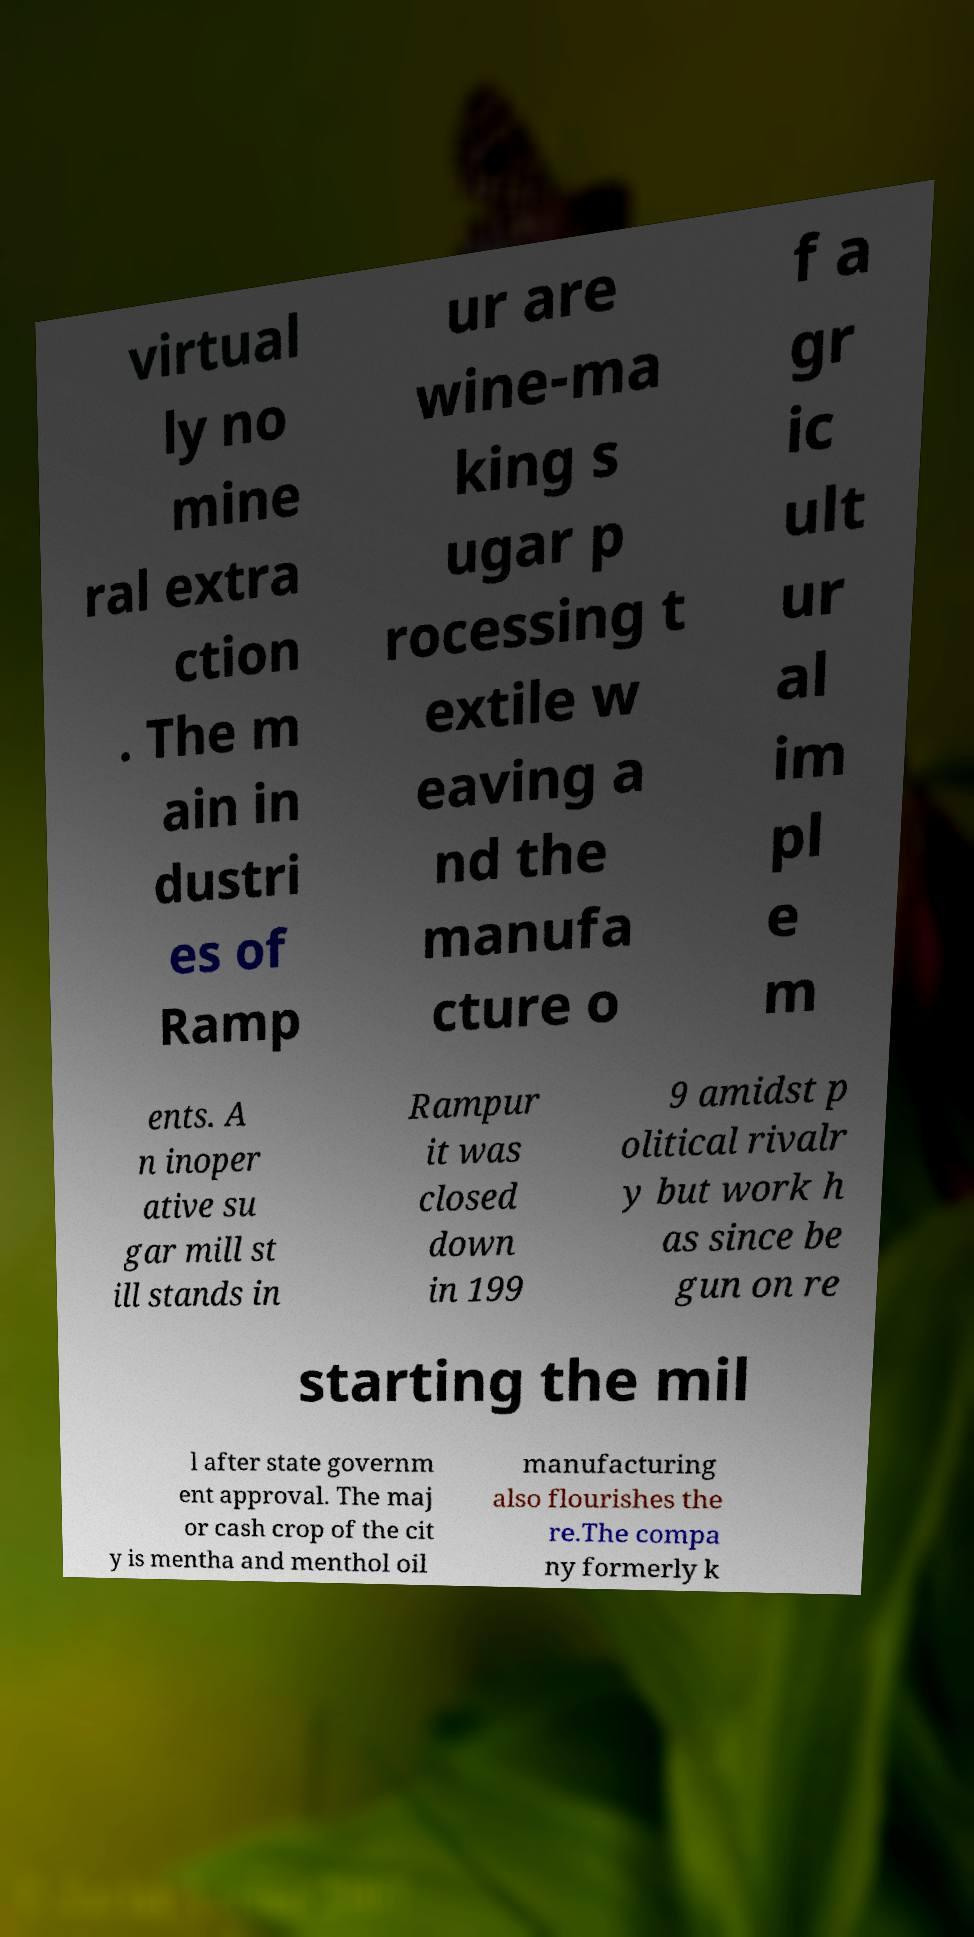Could you assist in decoding the text presented in this image and type it out clearly? virtual ly no mine ral extra ction . The m ain in dustri es of Ramp ur are wine-ma king s ugar p rocessing t extile w eaving a nd the manufa cture o f a gr ic ult ur al im pl e m ents. A n inoper ative su gar mill st ill stands in Rampur it was closed down in 199 9 amidst p olitical rivalr y but work h as since be gun on re starting the mil l after state governm ent approval. The maj or cash crop of the cit y is mentha and menthol oil manufacturing also flourishes the re.The compa ny formerly k 